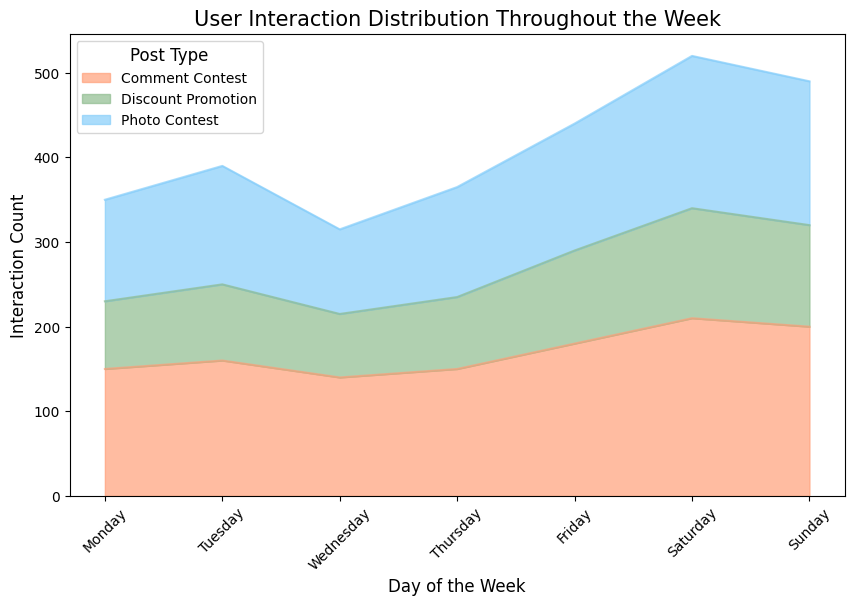Which day of the week sees the highest total user interaction? To find the highest total user interaction, look at the overall height of the stacked area chart for each day. The day with the tallest stacked area (across all post types) indicates the maximum combined interactions.
Answer: Saturday Which promotion type has the highest user interaction on Fridays? Check the areas corresponding to different promotion types for Friday. The one with the highest segment within the stack represents the maximum interaction count.
Answer: Comment Contest How do user interactions on Discount Promotions compare between Monday and Saturday? Compare the height of the green area representing Discount Promotions for Monday and Saturday. The height (or area) indicates the interaction count.
Answer: Saturday is higher What's the total interaction count for Tuesday? Sum up the heights of all areas for Tuesday (Photo Contest + Discount Promotion + Comment Contest). The heights correspond to 140 + 90 + 160 = 390.
Answer: 390 Which day experiences the smallest amount of user interaction for Comment Contests? Scan across the pink areas for Comment Contests and find the day with the smallest height, indicating the minimum interaction count.
Answer: Wednesday On which days does the Photo Contest have over 150 interactions? Identify the days where the height of the blue area (Photo Contest) exceeds the line for 150 interactions. Check which days meet this condition.
Answer: Friday, Saturday, Sunday How does the user interaction for Discount Promotions on Sunday compare to Thursday? Look at the height of the green areas for Discount Promotions on both Sunday and Thursday. Compare the difference in heights for these days.
Answer: Sunday is higher What's the percentage increase in user interaction for Photo Contests from Monday to Saturday? First, calculate the differences in interactions (180 - 120 = 60). Then, divide the increase by the initial amount on Monday and multiply by 100 to get the percentage: (60 / 120) * 100.
Answer: 50% How do the user interactions for Comment Contests vary between Wednesday and Friday? Examine the heights of the pink areas representing Comment Contests on Wednesday and Friday. The difference indicates how much interactions change.
Answer: Friday is higher Which promotional type consistently trends upward in interactions from Monday to Sunday? Observe the shape of the areas for each promotional type from Monday to Sunday. The one that consistently increases in height upward shows a rising trend in interactions.
Answer: None 